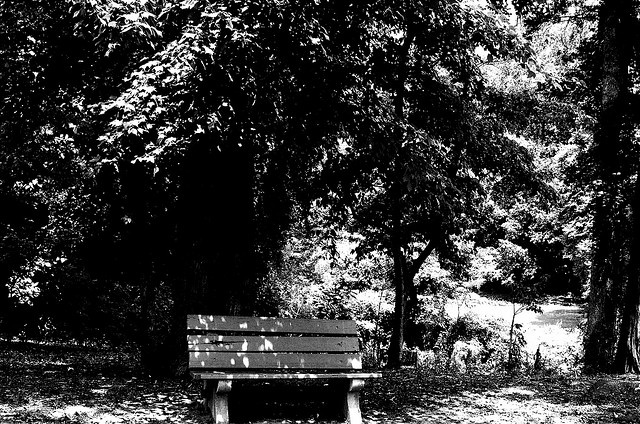Describe the objects in this image and their specific colors. I can see a bench in black, gray, darkgray, and white tones in this image. 